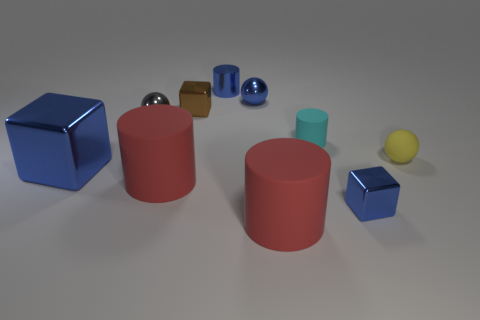What is the material of the tiny cyan object?
Keep it short and to the point. Rubber. How big is the metallic cube that is both to the right of the big blue shiny block and left of the cyan object?
Your answer should be compact. Small. What is the material of the cylinder that is the same color as the big shiny thing?
Provide a succinct answer. Metal. How many small balls are there?
Your answer should be compact. 3. Are there fewer gray things than tiny green cylinders?
Your answer should be compact. No. There is a blue sphere that is the same size as the yellow object; what is it made of?
Make the answer very short. Metal. What number of things are matte cylinders or tiny yellow balls?
Offer a terse response. 4. How many shiny objects are both left of the brown shiny block and in front of the tiny yellow ball?
Make the answer very short. 1. Is the number of red cylinders behind the big blue thing less than the number of red things?
Offer a very short reply. Yes. What shape is the cyan matte thing that is the same size as the gray thing?
Ensure brevity in your answer.  Cylinder. 